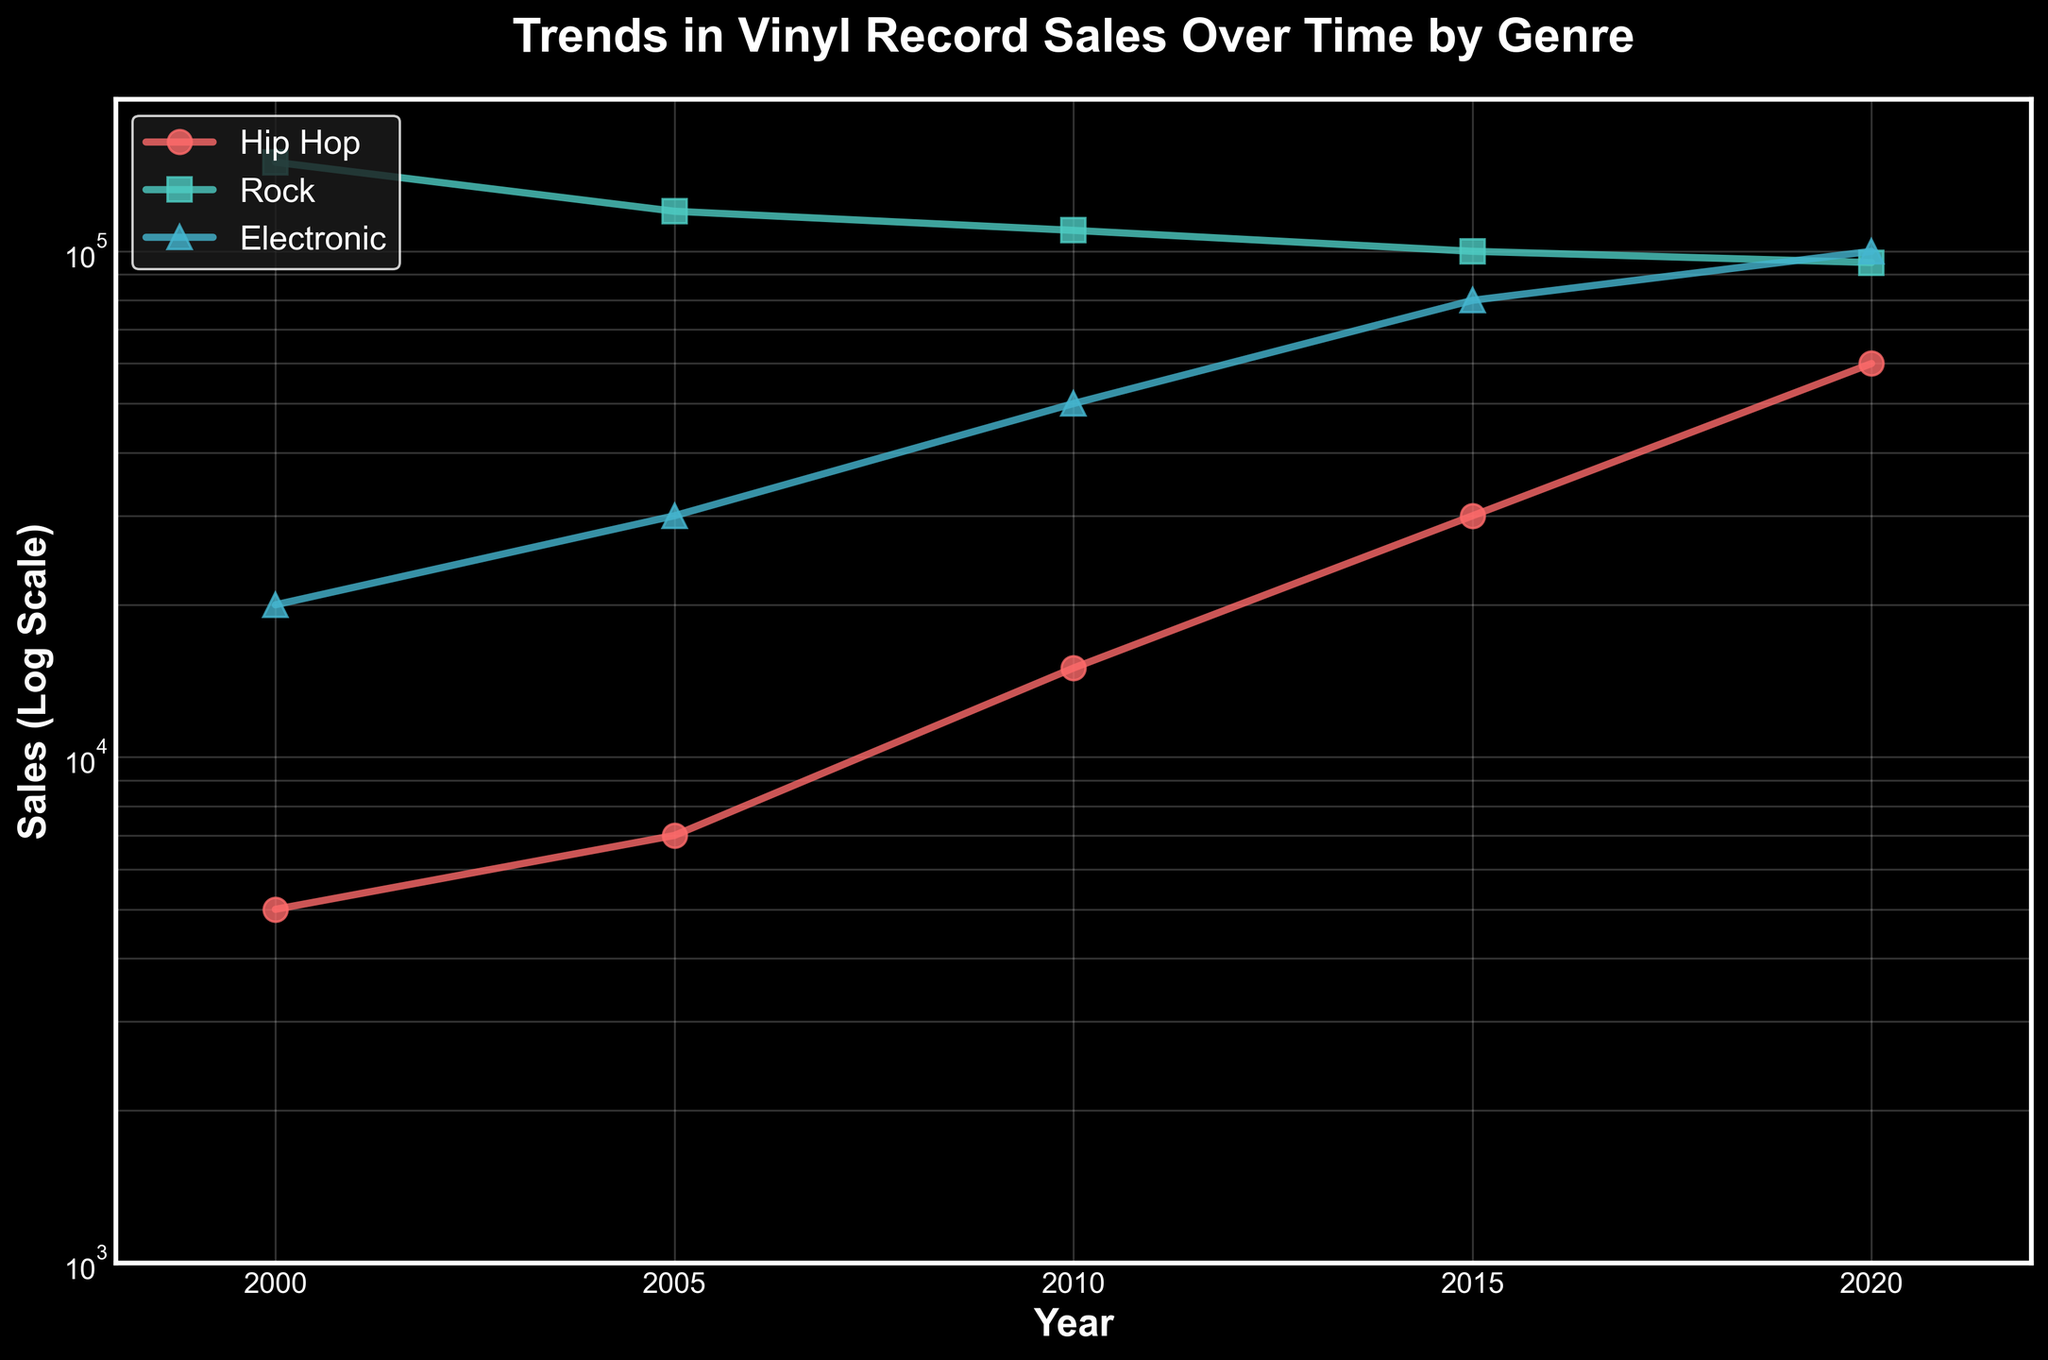What is the title of the figure? The title of the figure is located at the top and is usually in a larger font size compared to other text elements. Here, it explicitly mentions the main subject and the breakdown by genre.
Answer: Trends in Vinyl Record Sales Over Time by Genre How many genres are represented in the figure? The genres are represented by different colors and marker styles in the legend of the plot. By counting the distinct legend labels, we can see the genres represented in the figure.
Answer: 3 Which year shows the highest vinyl record sales for the Electronic genre? By examining the trend lines for the Electronic genre, which are likely color-coded (e.g., in light blue) and marked with specific markers, we can see the year corresponding to the peak value on the y-axis (sales axis).
Answer: 2020 What are the sales values for Hip Hop in 2000 and 2020? Locate the data points for Hip Hop at the years 2000 and 2020 on the x-axis. The y-axis value (sales) can be read directly or inferred from the log scale for these specific points.
Answer: 5000 in 2000 and 60000 in 2020 What genre had the highest sales in the year 2015? For 2015, find and compare the vertical positions of all genre-specific markers. The highest position on the y-axis log scale denotes the genre with the most sales in that year.
Answer: Rock What is the general trend for Rock vinyl record sales over time? By observing the Rock trend line, we evaluate whether the sales are increasing, decreasing, or fluctuating by following the line's direction from left (2000) to right (2020).
Answer: Decreasing What is the total vinyl record sales for all genres in 2005? Identify the individual sales values for each genre in 2005 and sum them up. The data points will show individual sales, and the total is the sum of these values.
Answer: 157000 Compare the sales trends for Hip Hop and Rock from 2000 to 2020. By analyzing the two trend lines from 2000 to 2020, we compare their slopes and values at various points, noting how Hip Hop sales rise while Rock's generally declines or stabilizes.
Answer: Hip Hop rising, Rock decreasing In which year did the sales for Electronic surpass those for Rock? Examine the trend lines for Electronic and Rock, particularly noting where the Electronic line starts to appear above the Rock line on the y-axis.
Answer: 2020 